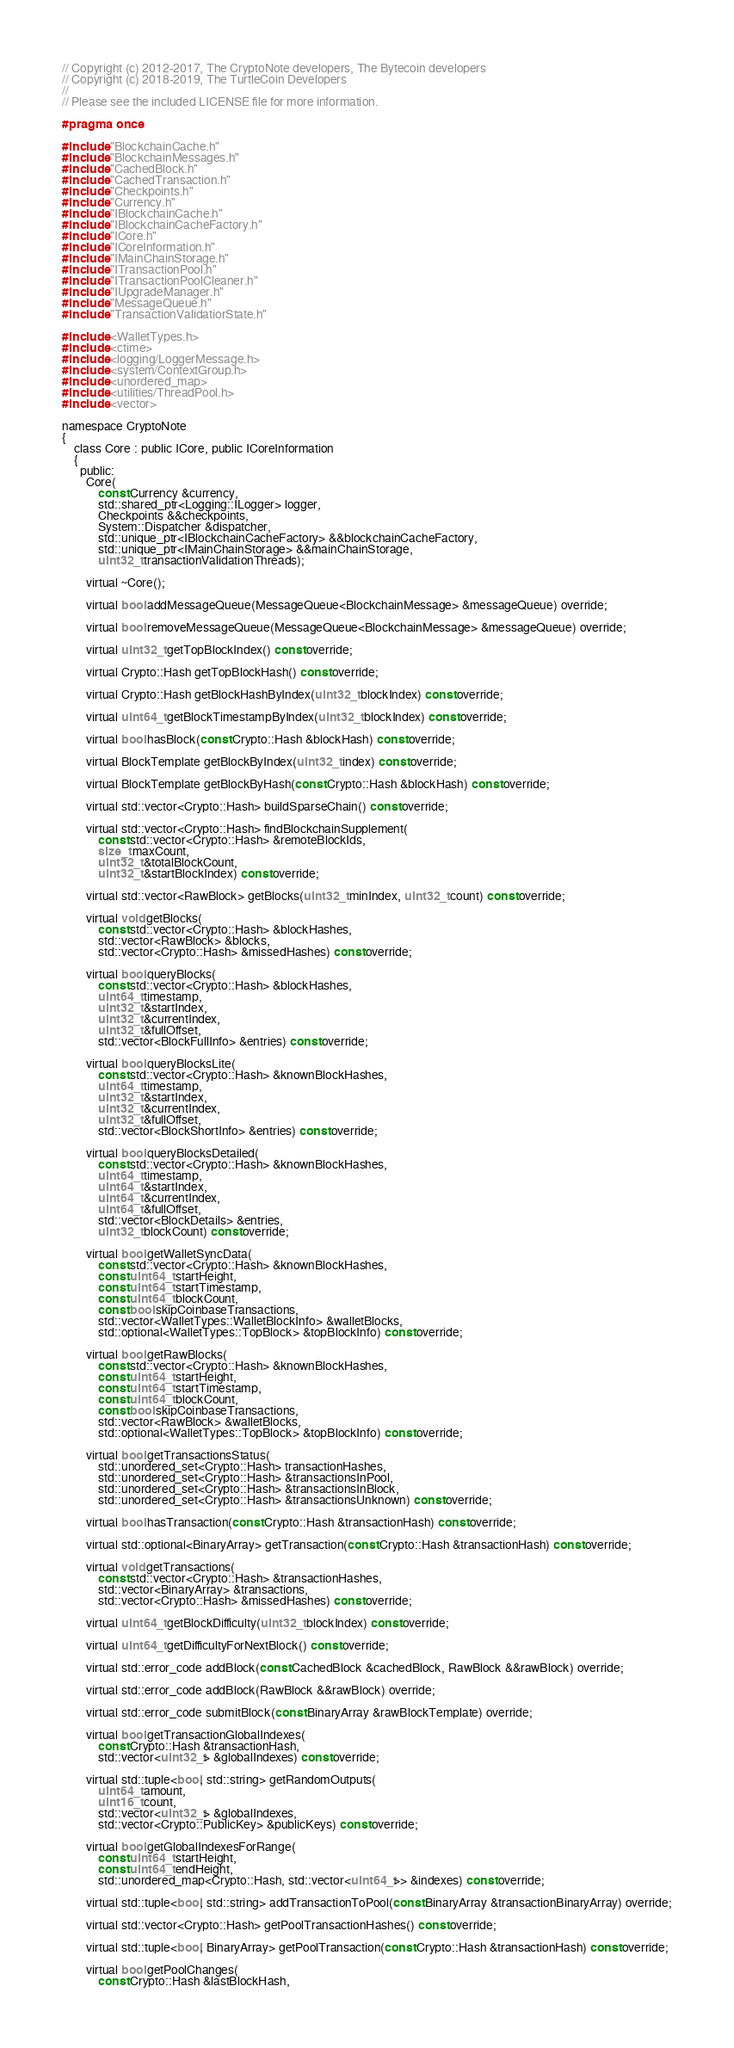Convert code to text. <code><loc_0><loc_0><loc_500><loc_500><_C_>// Copyright (c) 2012-2017, The CryptoNote developers, The Bytecoin developers
// Copyright (c) 2018-2019, The TurtleCoin Developers
//
// Please see the included LICENSE file for more information.

#pragma once

#include "BlockchainCache.h"
#include "BlockchainMessages.h"
#include "CachedBlock.h"
#include "CachedTransaction.h"
#include "Checkpoints.h"
#include "Currency.h"
#include "IBlockchainCache.h"
#include "IBlockchainCacheFactory.h"
#include "ICore.h"
#include "ICoreInformation.h"
#include "IMainChainStorage.h"
#include "ITransactionPool.h"
#include "ITransactionPoolCleaner.h"
#include "IUpgradeManager.h"
#include "MessageQueue.h"
#include "TransactionValidatiorState.h"

#include <WalletTypes.h>
#include <ctime>
#include <logging/LoggerMessage.h>
#include <system/ContextGroup.h>
#include <unordered_map>
#include <utilities/ThreadPool.h>
#include <vector>

namespace CryptoNote
{
    class Core : public ICore, public ICoreInformation
    {
      public:
        Core(
            const Currency &currency,
            std::shared_ptr<Logging::ILogger> logger,
            Checkpoints &&checkpoints,
            System::Dispatcher &dispatcher,
            std::unique_ptr<IBlockchainCacheFactory> &&blockchainCacheFactory,
            std::unique_ptr<IMainChainStorage> &&mainChainStorage,
            uint32_t transactionValidationThreads);

        virtual ~Core();

        virtual bool addMessageQueue(MessageQueue<BlockchainMessage> &messageQueue) override;

        virtual bool removeMessageQueue(MessageQueue<BlockchainMessage> &messageQueue) override;

        virtual uint32_t getTopBlockIndex() const override;

        virtual Crypto::Hash getTopBlockHash() const override;

        virtual Crypto::Hash getBlockHashByIndex(uint32_t blockIndex) const override;

        virtual uint64_t getBlockTimestampByIndex(uint32_t blockIndex) const override;

        virtual bool hasBlock(const Crypto::Hash &blockHash) const override;

        virtual BlockTemplate getBlockByIndex(uint32_t index) const override;

        virtual BlockTemplate getBlockByHash(const Crypto::Hash &blockHash) const override;

        virtual std::vector<Crypto::Hash> buildSparseChain() const override;

        virtual std::vector<Crypto::Hash> findBlockchainSupplement(
            const std::vector<Crypto::Hash> &remoteBlockIds,
            size_t maxCount,
            uint32_t &totalBlockCount,
            uint32_t &startBlockIndex) const override;

        virtual std::vector<RawBlock> getBlocks(uint32_t minIndex, uint32_t count) const override;

        virtual void getBlocks(
            const std::vector<Crypto::Hash> &blockHashes,
            std::vector<RawBlock> &blocks,
            std::vector<Crypto::Hash> &missedHashes) const override;

        virtual bool queryBlocks(
            const std::vector<Crypto::Hash> &blockHashes,
            uint64_t timestamp,
            uint32_t &startIndex,
            uint32_t &currentIndex,
            uint32_t &fullOffset,
            std::vector<BlockFullInfo> &entries) const override;

        virtual bool queryBlocksLite(
            const std::vector<Crypto::Hash> &knownBlockHashes,
            uint64_t timestamp,
            uint32_t &startIndex,
            uint32_t &currentIndex,
            uint32_t &fullOffset,
            std::vector<BlockShortInfo> &entries) const override;

        virtual bool queryBlocksDetailed(
            const std::vector<Crypto::Hash> &knownBlockHashes,
            uint64_t timestamp,
            uint64_t &startIndex,
            uint64_t &currentIndex,
            uint64_t &fullOffset,
            std::vector<BlockDetails> &entries,
            uint32_t blockCount) const override;

        virtual bool getWalletSyncData(
            const std::vector<Crypto::Hash> &knownBlockHashes,
            const uint64_t startHeight,
            const uint64_t startTimestamp,
            const uint64_t blockCount,
            const bool skipCoinbaseTransactions,
            std::vector<WalletTypes::WalletBlockInfo> &walletBlocks,
            std::optional<WalletTypes::TopBlock> &topBlockInfo) const override;

        virtual bool getRawBlocks(
            const std::vector<Crypto::Hash> &knownBlockHashes,
            const uint64_t startHeight,
            const uint64_t startTimestamp,
            const uint64_t blockCount,
            const bool skipCoinbaseTransactions,
            std::vector<RawBlock> &walletBlocks,
            std::optional<WalletTypes::TopBlock> &topBlockInfo) const override;

        virtual bool getTransactionsStatus(
            std::unordered_set<Crypto::Hash> transactionHashes,
            std::unordered_set<Crypto::Hash> &transactionsInPool,
            std::unordered_set<Crypto::Hash> &transactionsInBlock,
            std::unordered_set<Crypto::Hash> &transactionsUnknown) const override;

        virtual bool hasTransaction(const Crypto::Hash &transactionHash) const override;

        virtual std::optional<BinaryArray> getTransaction(const Crypto::Hash &transactionHash) const override;

        virtual void getTransactions(
            const std::vector<Crypto::Hash> &transactionHashes,
            std::vector<BinaryArray> &transactions,
            std::vector<Crypto::Hash> &missedHashes) const override;

        virtual uint64_t getBlockDifficulty(uint32_t blockIndex) const override;

        virtual uint64_t getDifficultyForNextBlock() const override;

        virtual std::error_code addBlock(const CachedBlock &cachedBlock, RawBlock &&rawBlock) override;

        virtual std::error_code addBlock(RawBlock &&rawBlock) override;

        virtual std::error_code submitBlock(const BinaryArray &rawBlockTemplate) override;

        virtual bool getTransactionGlobalIndexes(
            const Crypto::Hash &transactionHash,
            std::vector<uint32_t> &globalIndexes) const override;

        virtual std::tuple<bool, std::string> getRandomOutputs(
            uint64_t amount,
            uint16_t count,
            std::vector<uint32_t> &globalIndexes,
            std::vector<Crypto::PublicKey> &publicKeys) const override;

        virtual bool getGlobalIndexesForRange(
            const uint64_t startHeight,
            const uint64_t endHeight,
            std::unordered_map<Crypto::Hash, std::vector<uint64_t>> &indexes) const override;

        virtual std::tuple<bool, std::string> addTransactionToPool(const BinaryArray &transactionBinaryArray) override;

        virtual std::vector<Crypto::Hash> getPoolTransactionHashes() const override;

        virtual std::tuple<bool, BinaryArray> getPoolTransaction(const Crypto::Hash &transactionHash) const override;

        virtual bool getPoolChanges(
            const Crypto::Hash &lastBlockHash,</code> 